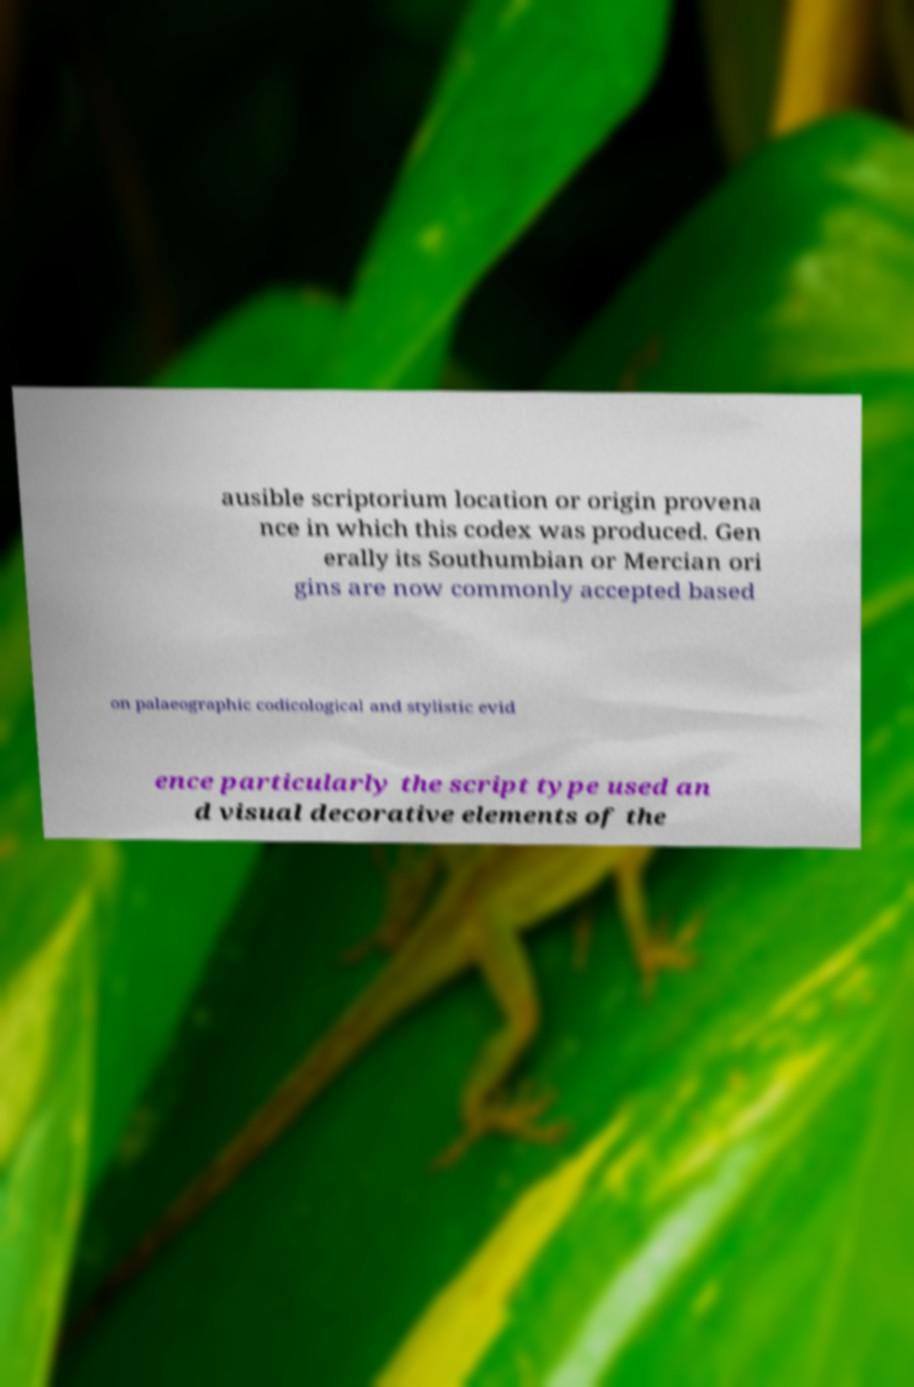For documentation purposes, I need the text within this image transcribed. Could you provide that? ausible scriptorium location or origin provena nce in which this codex was produced. Gen erally its Southumbian or Mercian ori gins are now commonly accepted based on palaeographic codicological and stylistic evid ence particularly the script type used an d visual decorative elements of the 